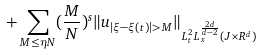<formula> <loc_0><loc_0><loc_500><loc_500>+ \sum _ { M \leq \eta N } ( \frac { M } { N } ) ^ { s } \| u _ { | \xi - \xi ( t ) | > M } \| _ { L _ { t } ^ { 2 } L _ { x } ^ { \frac { 2 d } { d - 2 } } ( J \times R ^ { d } ) }</formula> 